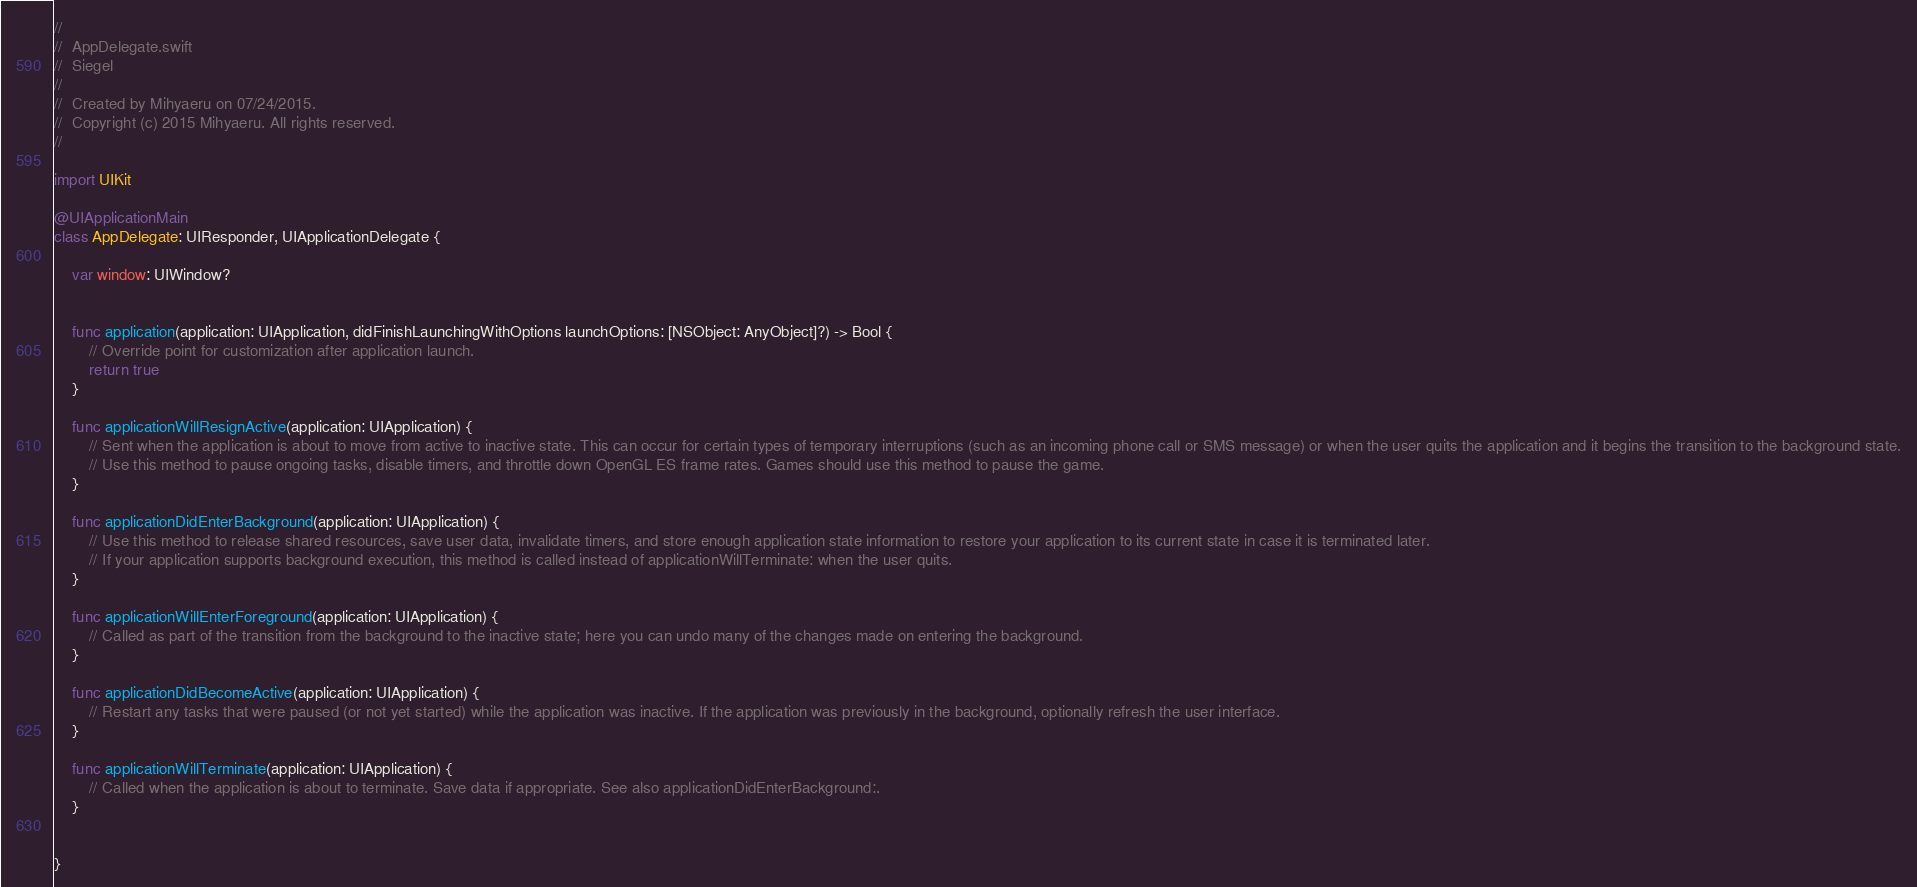<code> <loc_0><loc_0><loc_500><loc_500><_Swift_>//
//  AppDelegate.swift
//  Siegel
//
//  Created by Mihyaeru on 07/24/2015.
//  Copyright (c) 2015 Mihyaeru. All rights reserved.
//

import UIKit

@UIApplicationMain
class AppDelegate: UIResponder, UIApplicationDelegate {

    var window: UIWindow?


    func application(application: UIApplication, didFinishLaunchingWithOptions launchOptions: [NSObject: AnyObject]?) -> Bool {
        // Override point for customization after application launch.
        return true
    }

    func applicationWillResignActive(application: UIApplication) {
        // Sent when the application is about to move from active to inactive state. This can occur for certain types of temporary interruptions (such as an incoming phone call or SMS message) or when the user quits the application and it begins the transition to the background state.
        // Use this method to pause ongoing tasks, disable timers, and throttle down OpenGL ES frame rates. Games should use this method to pause the game.
    }

    func applicationDidEnterBackground(application: UIApplication) {
        // Use this method to release shared resources, save user data, invalidate timers, and store enough application state information to restore your application to its current state in case it is terminated later.
        // If your application supports background execution, this method is called instead of applicationWillTerminate: when the user quits.
    }

    func applicationWillEnterForeground(application: UIApplication) {
        // Called as part of the transition from the background to the inactive state; here you can undo many of the changes made on entering the background.
    }

    func applicationDidBecomeActive(application: UIApplication) {
        // Restart any tasks that were paused (or not yet started) while the application was inactive. If the application was previously in the background, optionally refresh the user interface.
    }

    func applicationWillTerminate(application: UIApplication) {
        // Called when the application is about to terminate. Save data if appropriate. See also applicationDidEnterBackground:.
    }


}

</code> 